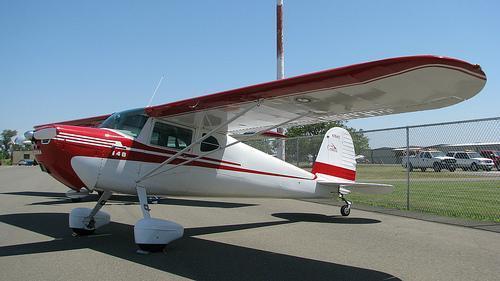How many wheels does this plane have?
Give a very brief answer. 3. How many wheels does the plane have?
Give a very brief answer. 3. 